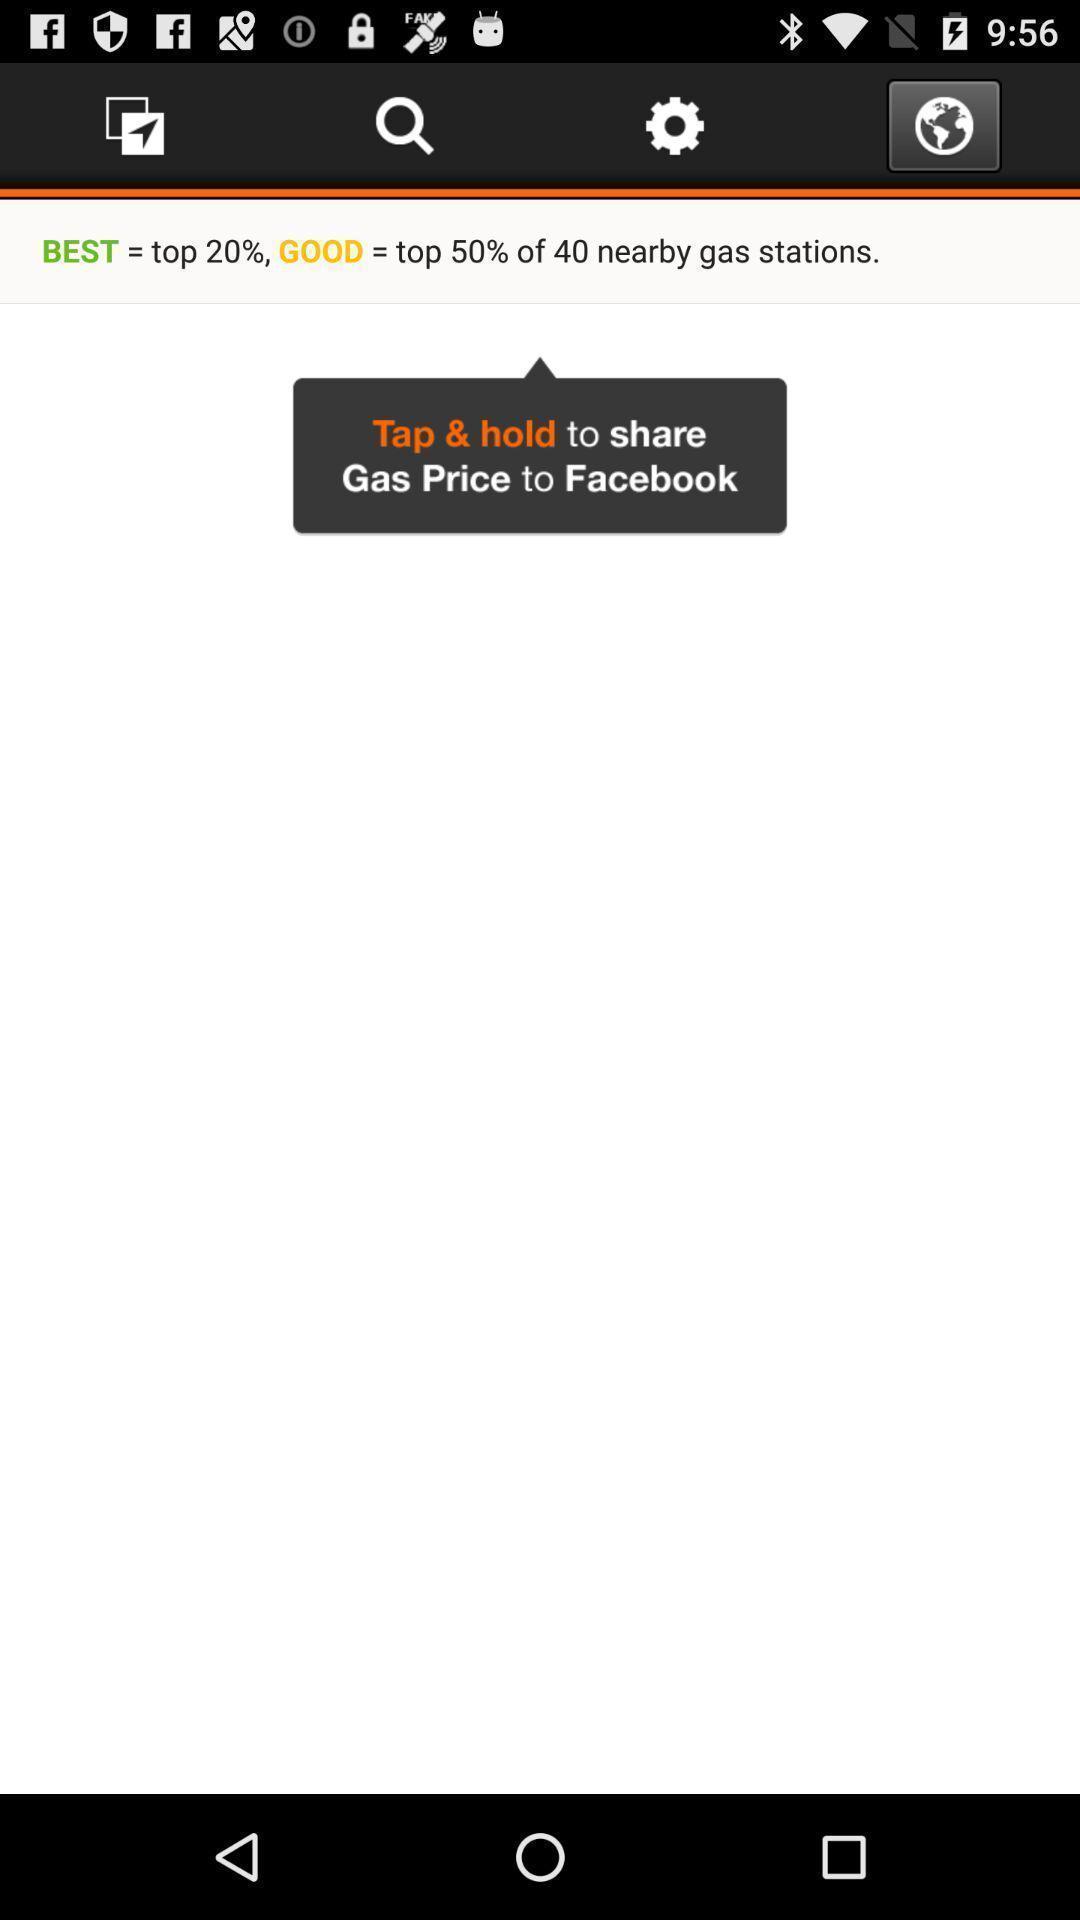Summarize the information in this screenshot. Screen shows display of a pop up to share. 